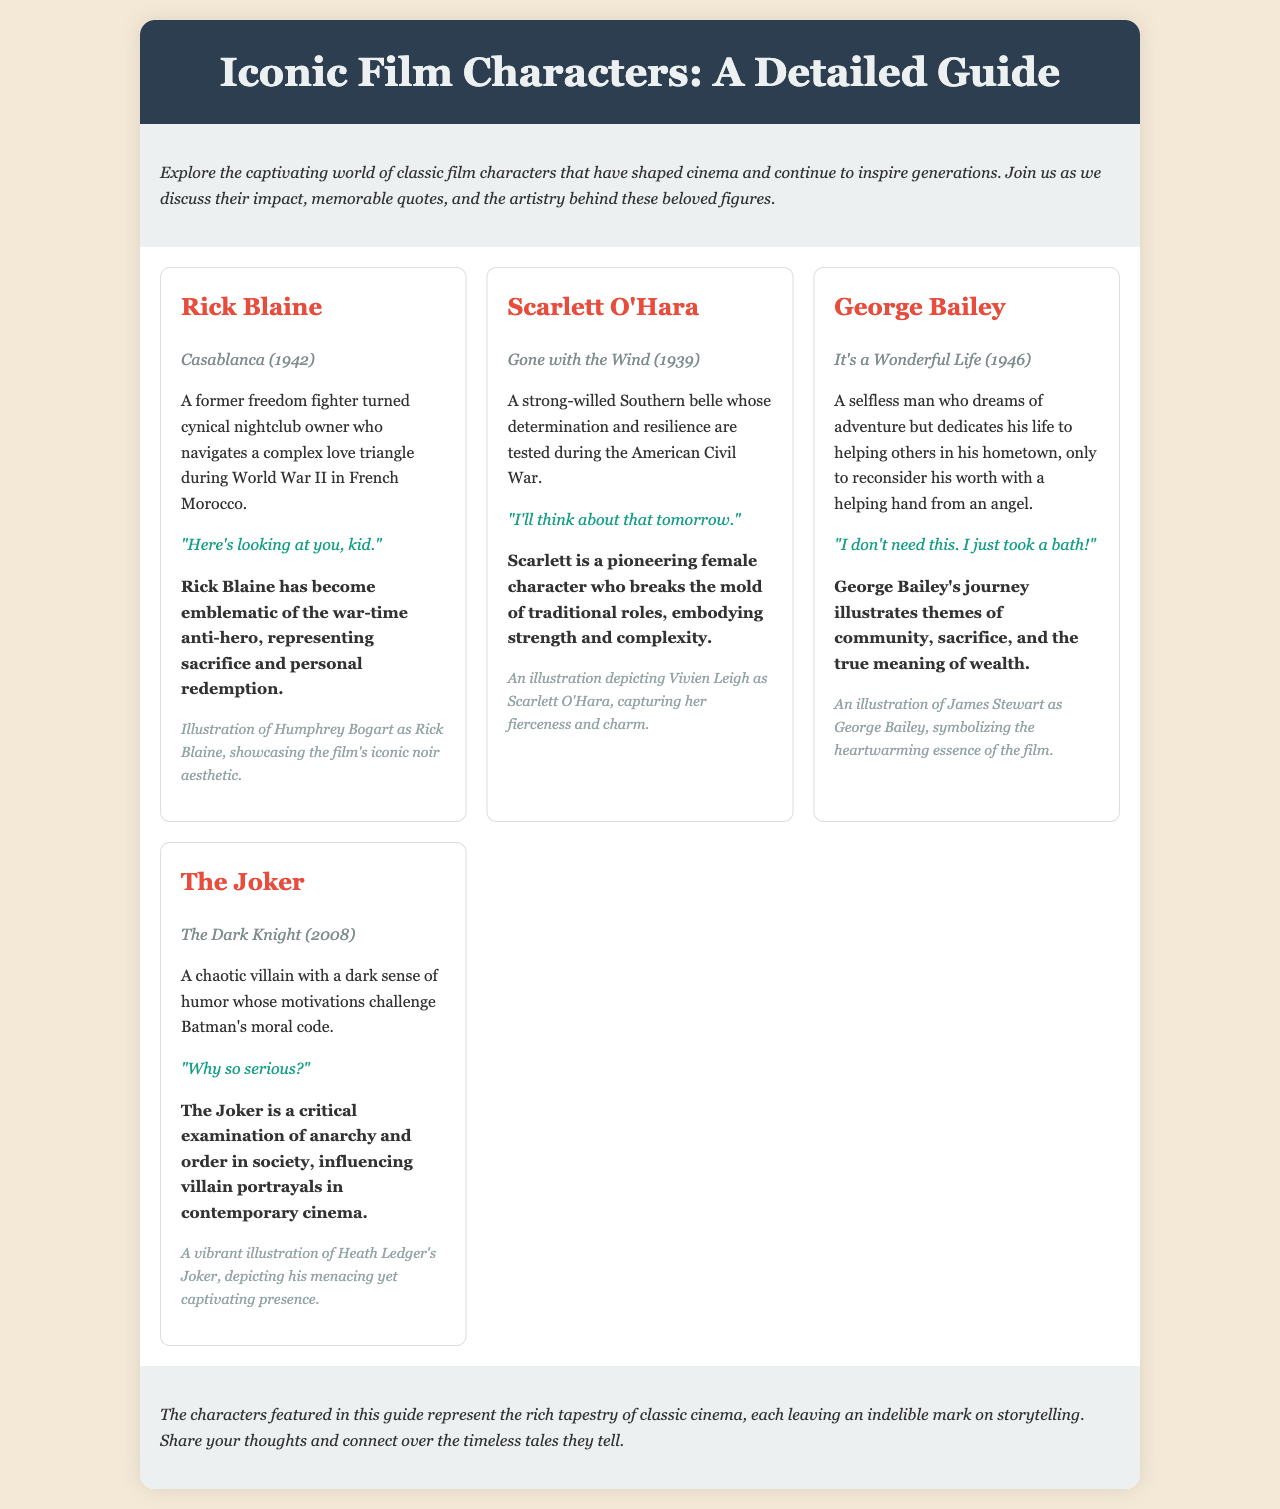What is the name of the character from Casablanca? The character from Casablanca is Rick Blaine.
Answer: Rick Blaine In which year was Gone with the Wind released? The year Gone with the Wind was released is mentioned in the brochure.
Answer: 1939 What is George Bailey's quote in It's a Wonderful Life? The quote attributed to George Bailey is provided in the brochure.
Answer: "I don't need this. I just took a bath!" Which character is known for the line "Why so serious?" The line "Why so serious?" is associated with a specific character in the document.
Answer: The Joker What iconic role is played by Vivien Leigh? The document specifies the character played by Vivien Leigh.
Answer: Scarlett O'Hara How many characters are discussed in the document? The number of characters featured in the character grid can be counted from the brochure.
Answer: Four What impact does Rick Blaine represent according to the brochure? The document describes the type of impact Rick Blaine has had on cinema.
Answer: War-time anti-hero Which film features the character known for chaos and dark humor? The film associated with the chaotic character is specified in the document.
Answer: The Dark Knight 